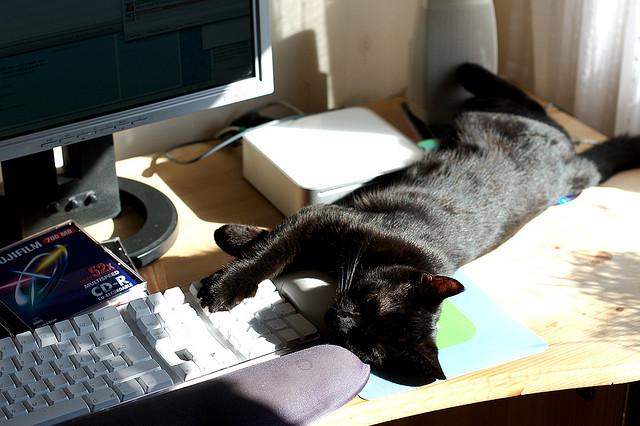What is the white thing the cat's back paw is touching?
Quick response, please. Keyboard. Is the cat warm or cold?
Be succinct. Warm. Is the cats name Luna?
Answer briefly. No. 